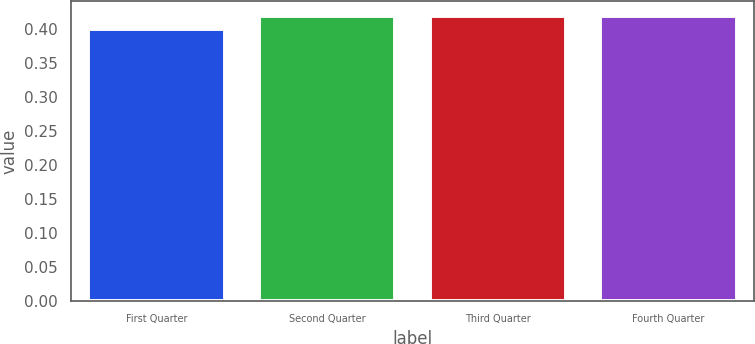Convert chart. <chart><loc_0><loc_0><loc_500><loc_500><bar_chart><fcel>First Quarter<fcel>Second Quarter<fcel>Third Quarter<fcel>Fourth Quarter<nl><fcel>0.4<fcel>0.42<fcel>0.42<fcel>0.42<nl></chart> 